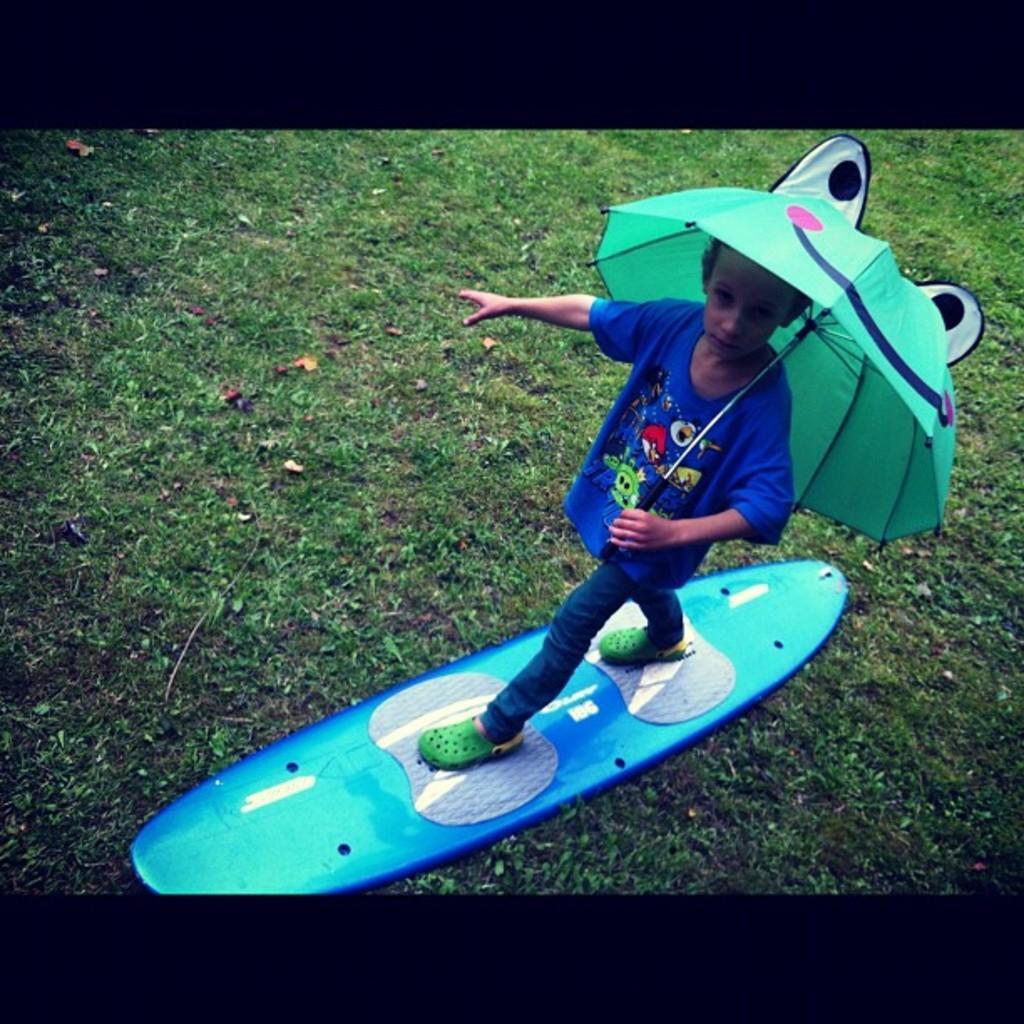How would you summarize this image in a sentence or two? In this image we can see a boy standing on the surfing board and holding an umbrella. At the bottom there is grass. 